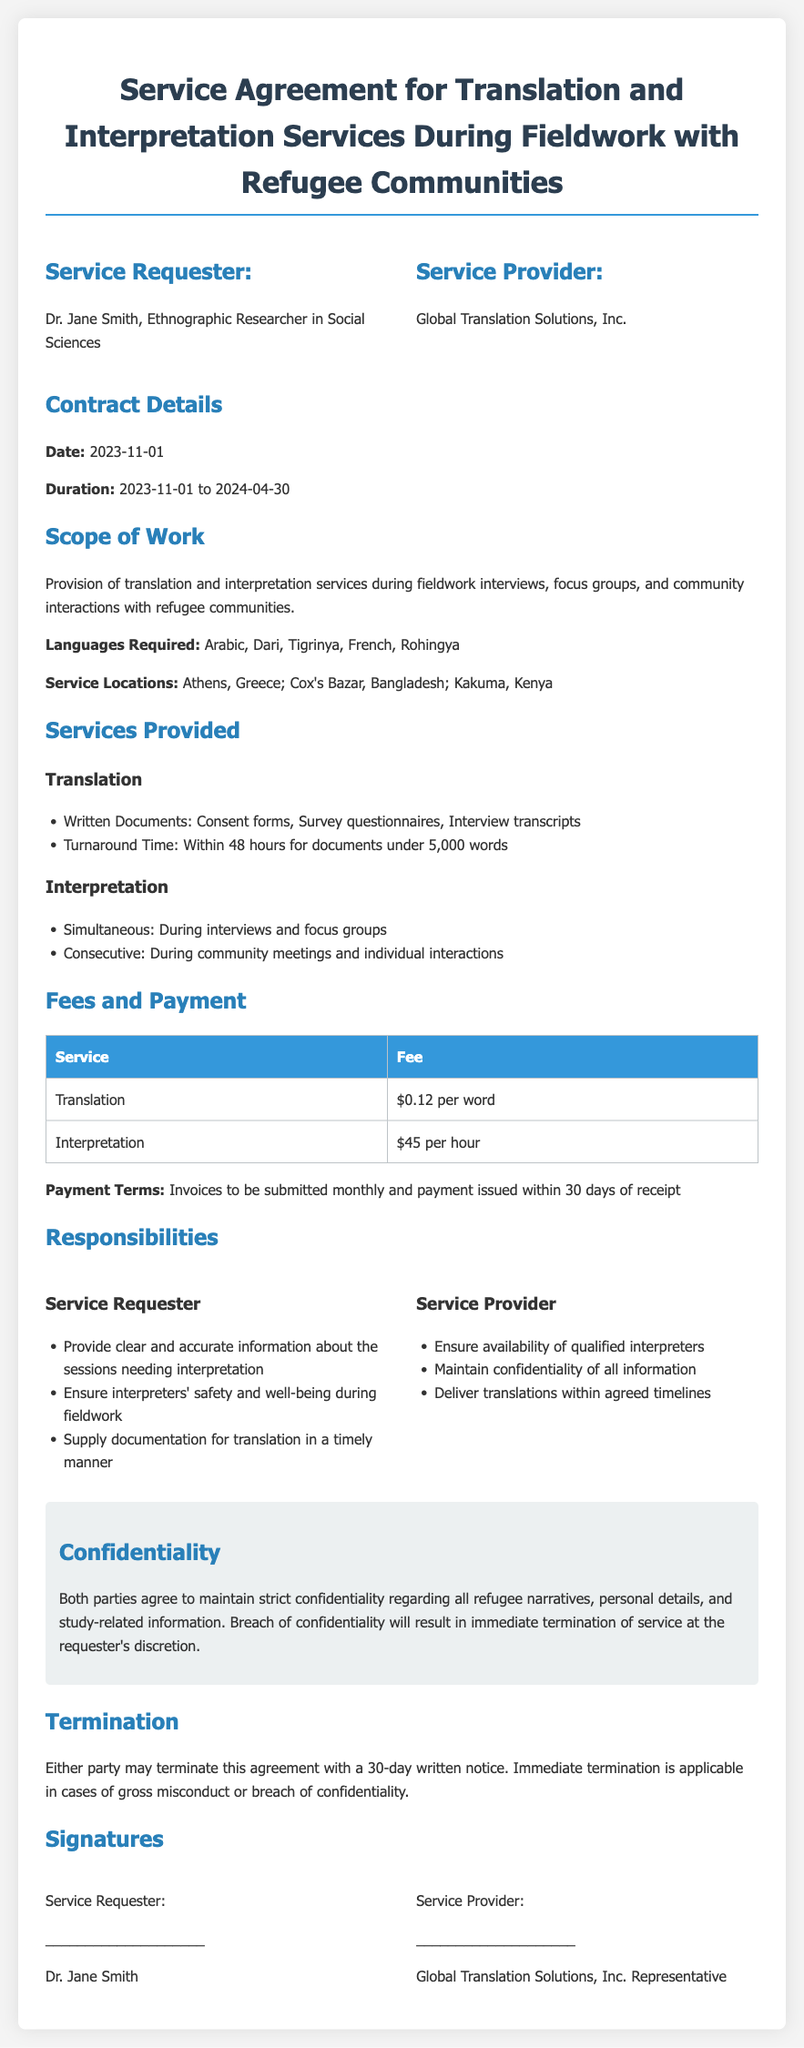What is the service requester’s name? The service requester is Dr. Jane Smith, as noted in the document.
Answer: Dr. Jane Smith What is the service provider’s name? The service provider is Global Translation Solutions, Inc.
Answer: Global Translation Solutions, Inc What is the start date of the service agreement? The document specifies that the service agreement starts on 2023-11-01.
Answer: 2023-11-01 What is the duration of the contract? The duration as mentioned in the document is from 2023-11-01 to 2024-04-30.
Answer: 2023-11-01 to 2024-04-30 What languages are required for the services? According to the scope of work, the required languages are Arabic, Dari, Tigrinya, French, and Rohingya.
Answer: Arabic, Dari, Tigrinya, French, Rohingya What is the fee per word for translation services? The fee for translation services is $0.12 per word as stated in the fees section.
Answer: $0.12 per word What is the turnaround time for translations under 5,000 words? The document mentions a turnaround time of within 48 hours for such translations.
Answer: Within 48 hours What happens if confidentiality is breached? A breach of confidentiality will lead to immediate termination of service at the requester's discretion.
Answer: Immediate termination How can either party terminate the agreement? Either party may terminate the agreement with a 30-day written notice.
Answer: 30-day written notice 